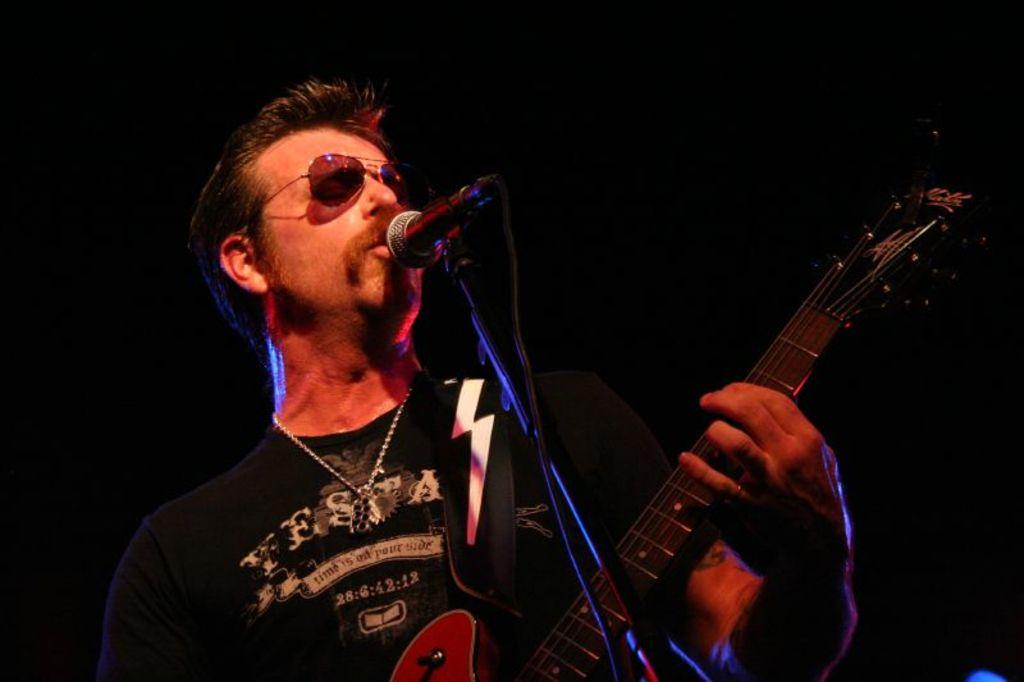What is the person in the image doing? The person is holding a guitar in the image. Can you describe any accessories the person is wearing? The person is wearing glasses in the image. What other objects can be seen in the image? There is a microphone and a stand in the image. What type of wren can be seen perched on the guitar in the image? There is no wren present in the image; the person is holding a guitar without any birds on it. 